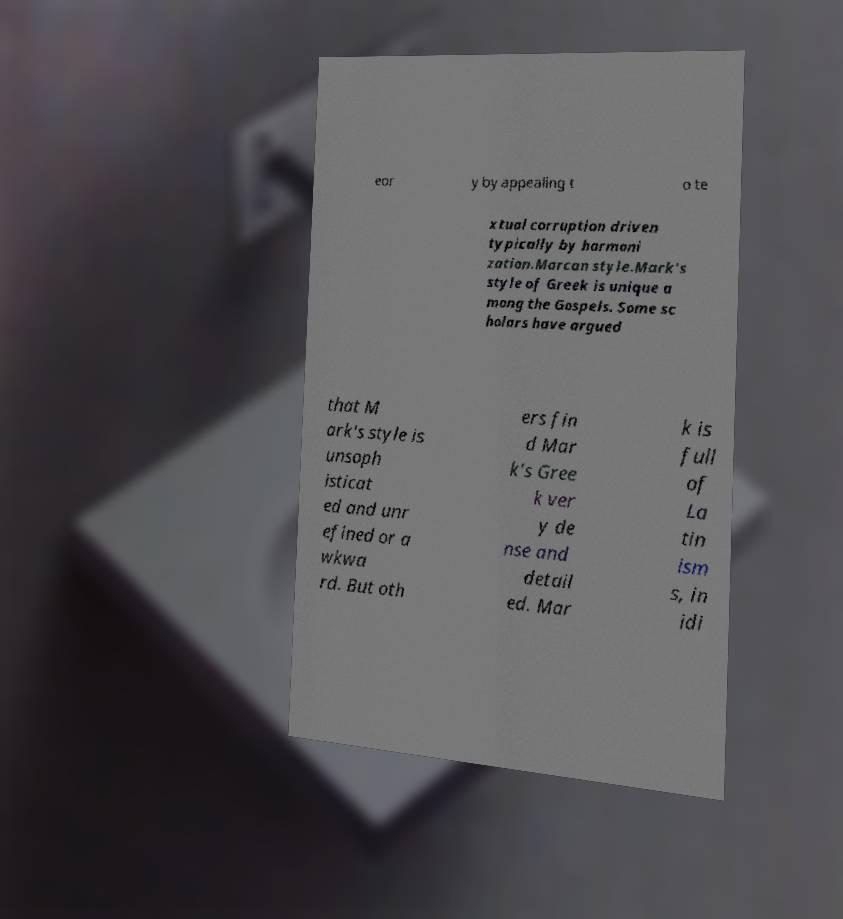I need the written content from this picture converted into text. Can you do that? eor y by appealing t o te xtual corruption driven typically by harmoni zation.Marcan style.Mark's style of Greek is unique a mong the Gospels. Some sc holars have argued that M ark's style is unsoph isticat ed and unr efined or a wkwa rd. But oth ers fin d Mar k's Gree k ver y de nse and detail ed. Mar k is full of La tin ism s, in idi 